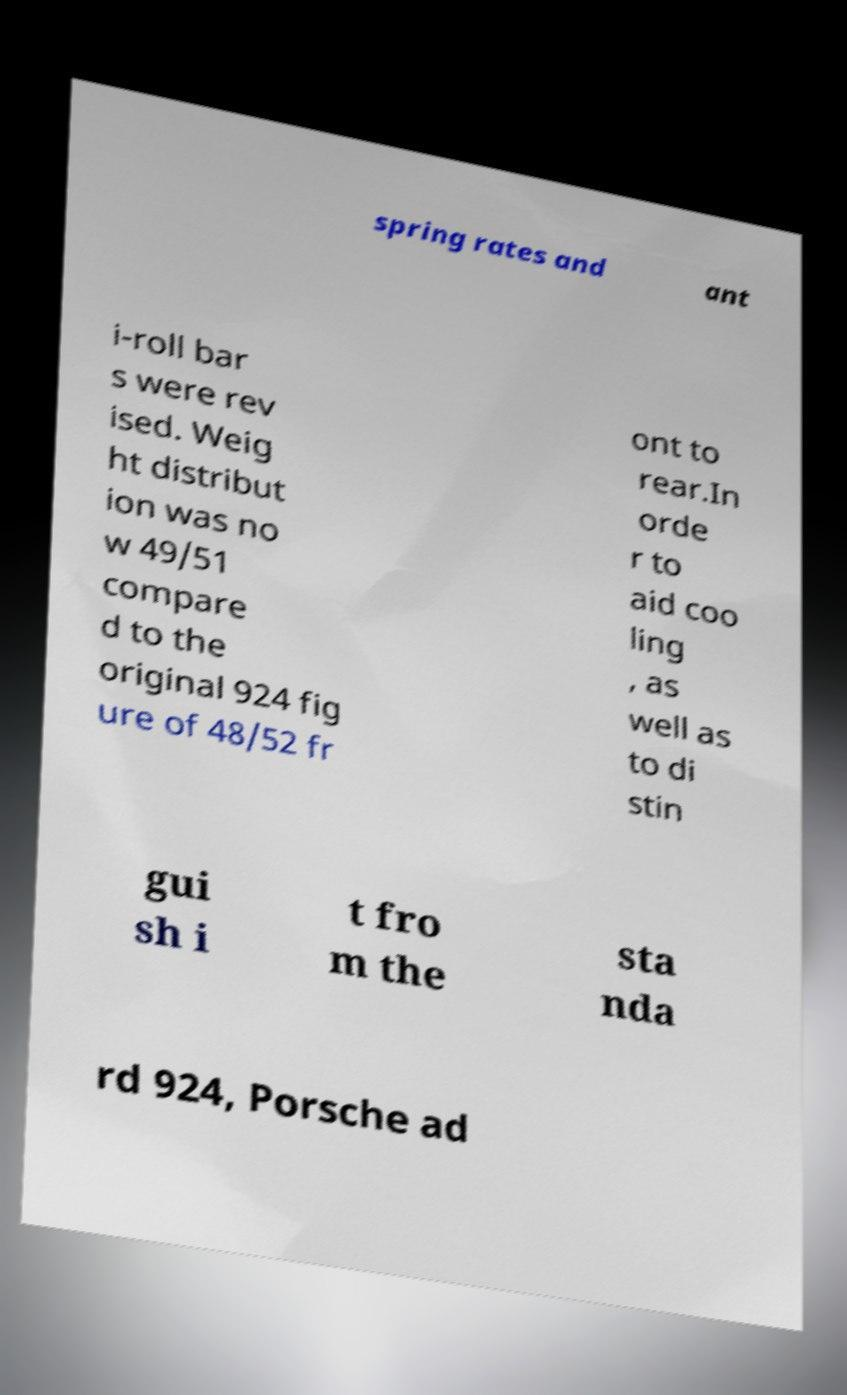Please read and relay the text visible in this image. What does it say? spring rates and ant i-roll bar s were rev ised. Weig ht distribut ion was no w 49/51 compare d to the original 924 fig ure of 48/52 fr ont to rear.In orde r to aid coo ling , as well as to di stin gui sh i t fro m the sta nda rd 924, Porsche ad 